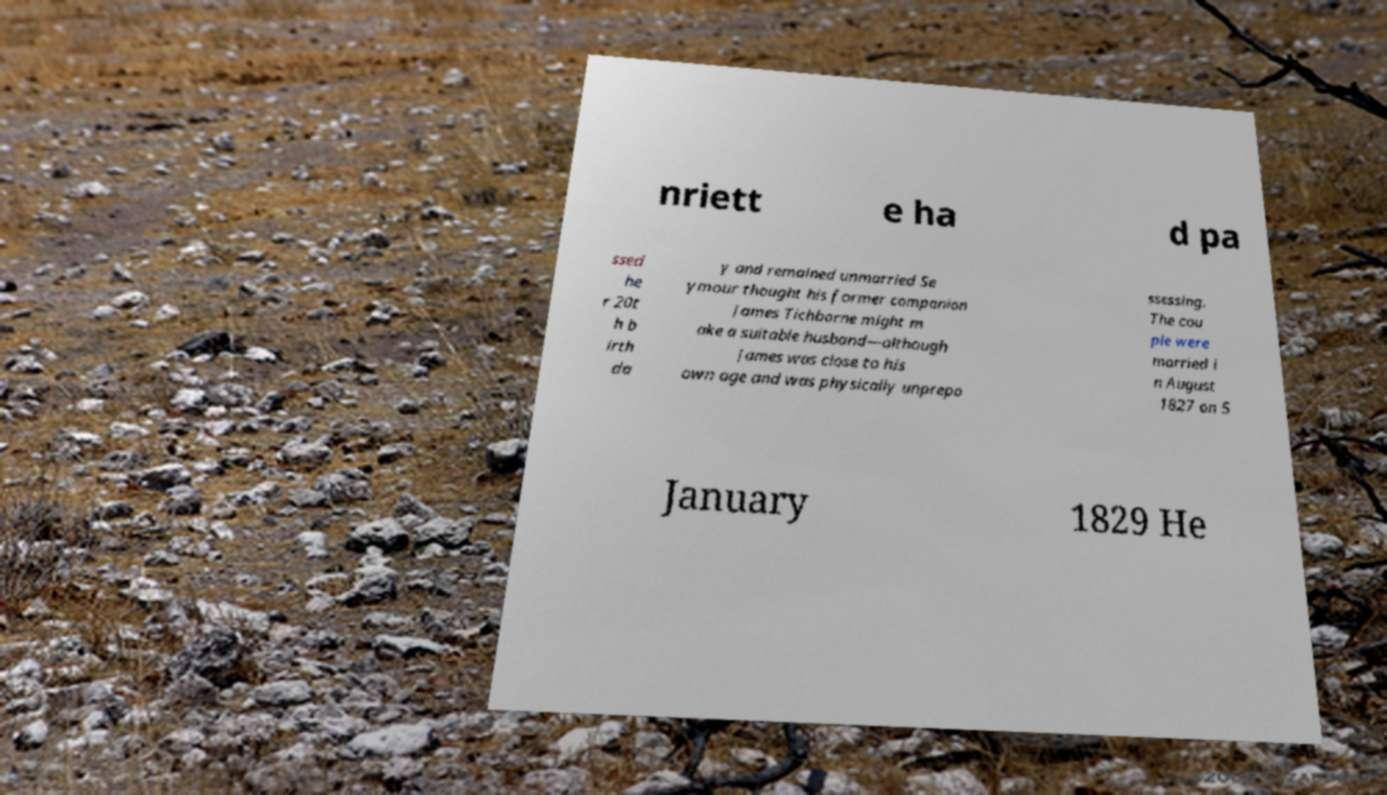What messages or text are displayed in this image? I need them in a readable, typed format. nriett e ha d pa ssed he r 20t h b irth da y and remained unmarried Se ymour thought his former companion James Tichborne might m ake a suitable husband—although James was close to his own age and was physically unprepo ssessing. The cou ple were married i n August 1827 on 5 January 1829 He 